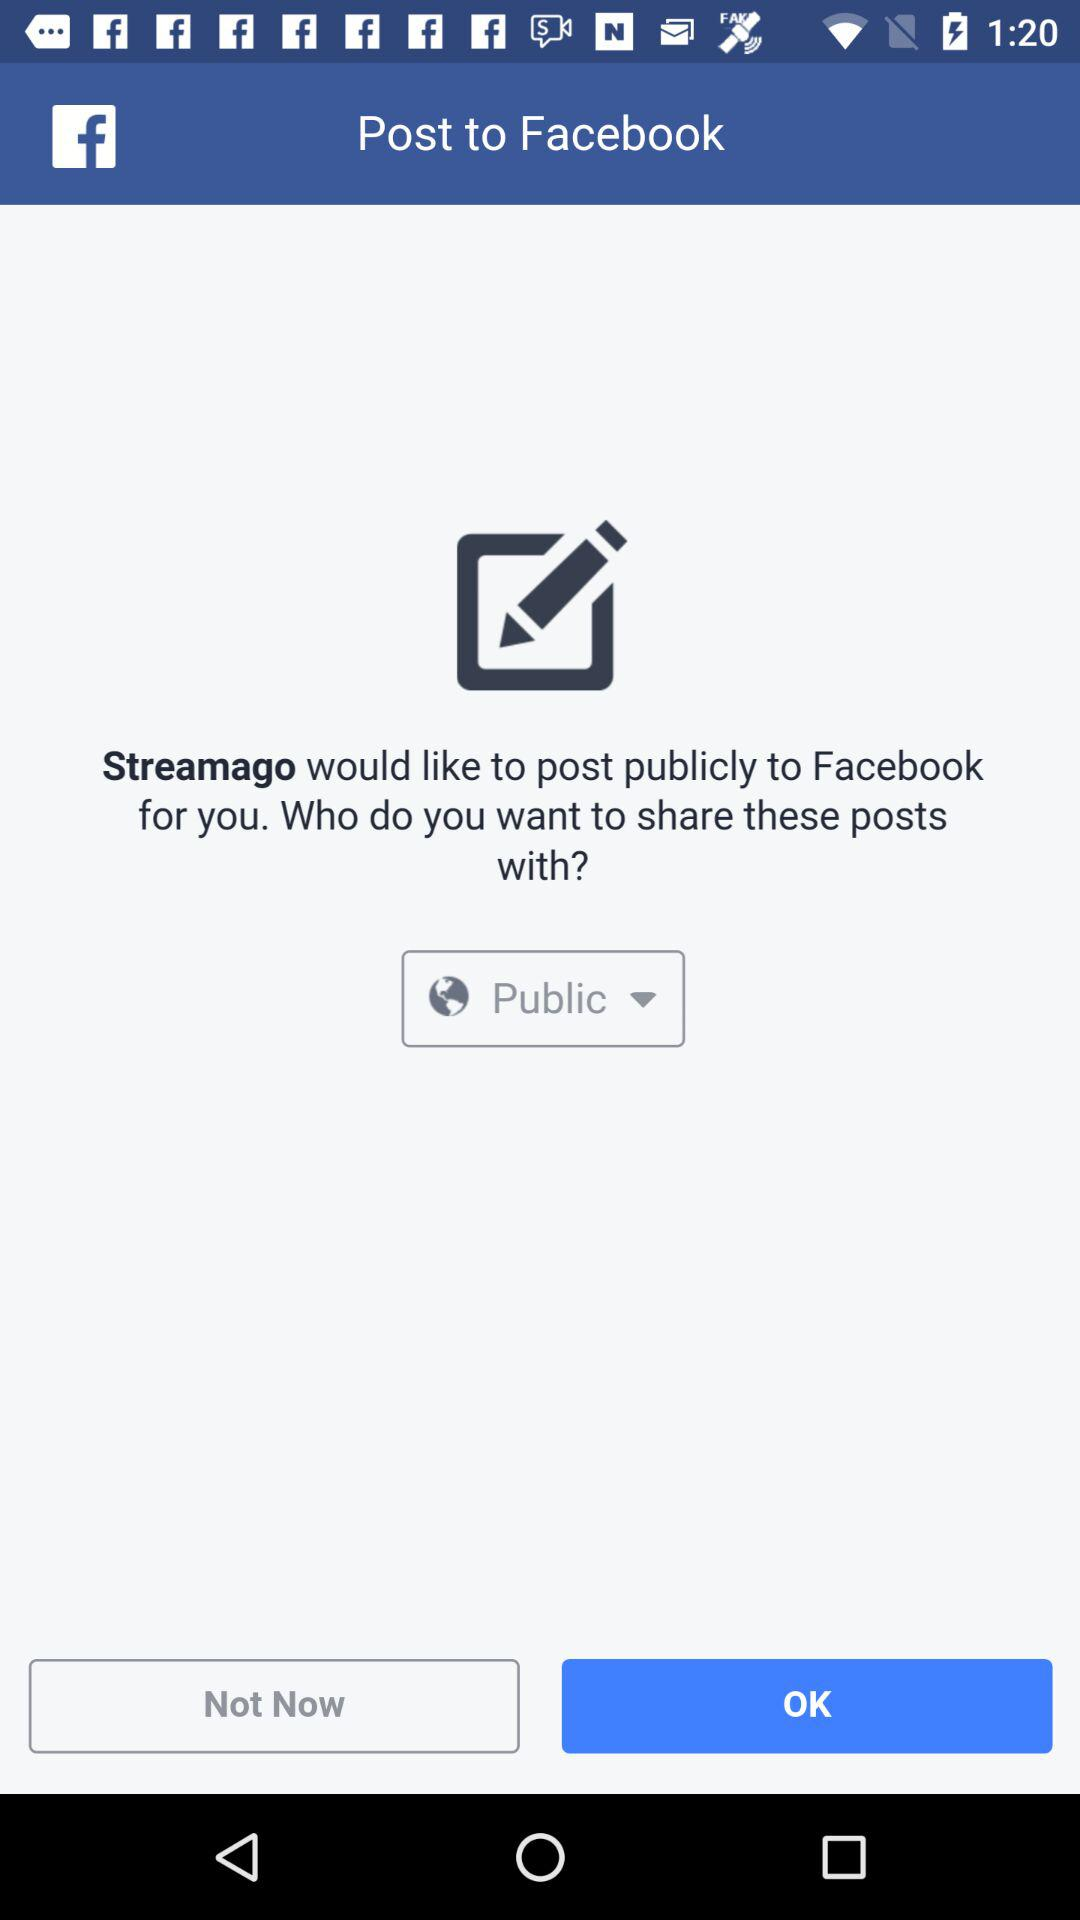With whom can the post be shared? The post can be shared with "Public". 